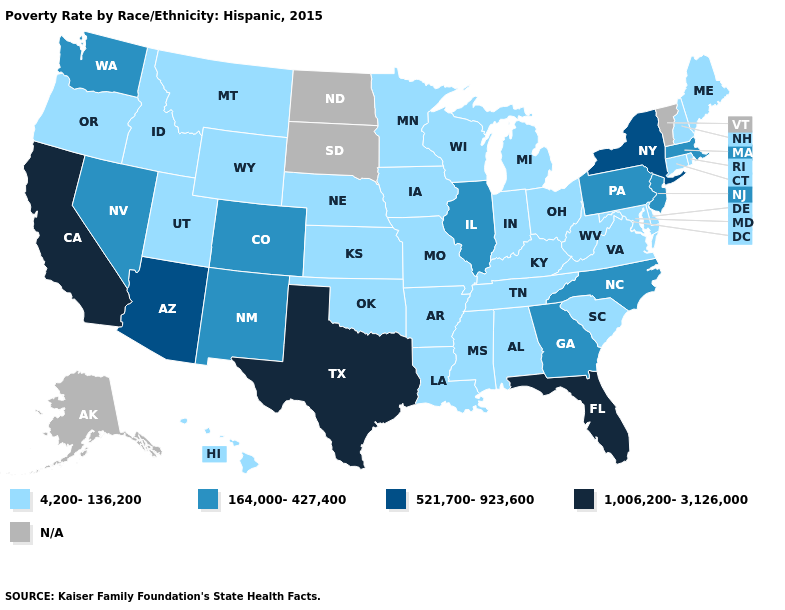Name the states that have a value in the range 1,006,200-3,126,000?
Answer briefly. California, Florida, Texas. What is the value of Delaware?
Keep it brief. 4,200-136,200. Which states have the highest value in the USA?
Concise answer only. California, Florida, Texas. Among the states that border Kansas , does Colorado have the lowest value?
Answer briefly. No. Name the states that have a value in the range 521,700-923,600?
Keep it brief. Arizona, New York. What is the highest value in states that border Massachusetts?
Answer briefly. 521,700-923,600. Name the states that have a value in the range 4,200-136,200?
Keep it brief. Alabama, Arkansas, Connecticut, Delaware, Hawaii, Idaho, Indiana, Iowa, Kansas, Kentucky, Louisiana, Maine, Maryland, Michigan, Minnesota, Mississippi, Missouri, Montana, Nebraska, New Hampshire, Ohio, Oklahoma, Oregon, Rhode Island, South Carolina, Tennessee, Utah, Virginia, West Virginia, Wisconsin, Wyoming. How many symbols are there in the legend?
Concise answer only. 5. Does Texas have the highest value in the USA?
Short answer required. Yes. Does Georgia have the highest value in the USA?
Answer briefly. No. Name the states that have a value in the range 4,200-136,200?
Quick response, please. Alabama, Arkansas, Connecticut, Delaware, Hawaii, Idaho, Indiana, Iowa, Kansas, Kentucky, Louisiana, Maine, Maryland, Michigan, Minnesota, Mississippi, Missouri, Montana, Nebraska, New Hampshire, Ohio, Oklahoma, Oregon, Rhode Island, South Carolina, Tennessee, Utah, Virginia, West Virginia, Wisconsin, Wyoming. Which states have the lowest value in the USA?
Give a very brief answer. Alabama, Arkansas, Connecticut, Delaware, Hawaii, Idaho, Indiana, Iowa, Kansas, Kentucky, Louisiana, Maine, Maryland, Michigan, Minnesota, Mississippi, Missouri, Montana, Nebraska, New Hampshire, Ohio, Oklahoma, Oregon, Rhode Island, South Carolina, Tennessee, Utah, Virginia, West Virginia, Wisconsin, Wyoming. 